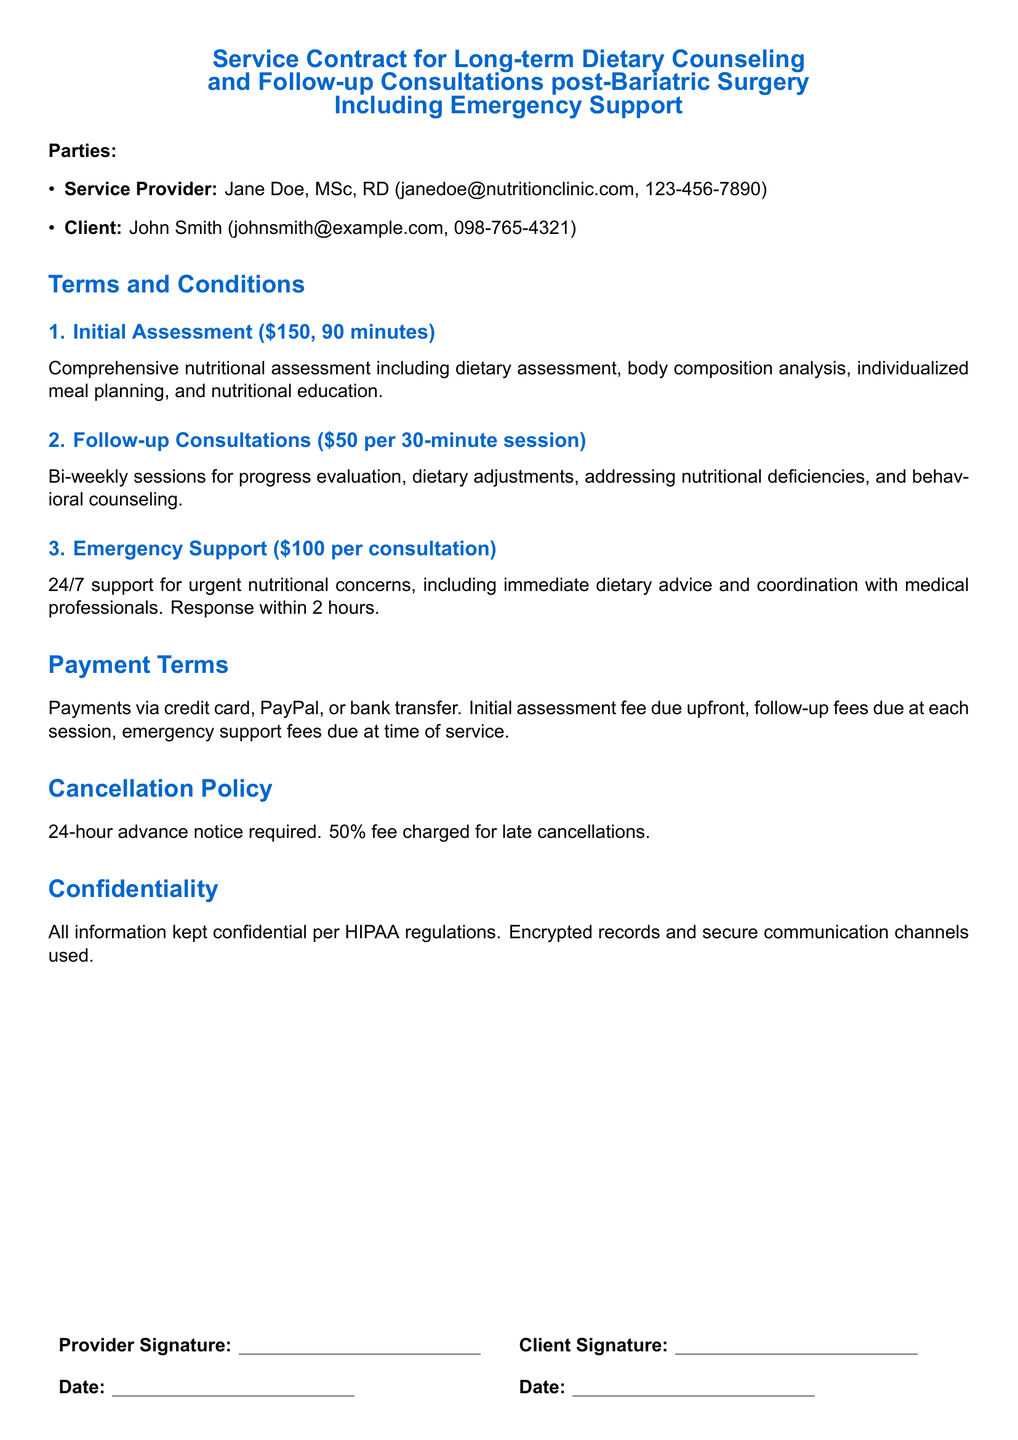What is the name of the service provider? The service provider is specifically named in the document, which is Jane Doe.
Answer: Jane Doe What is the fee for the initial assessment? The fee for the initial assessment is clearly stated in the document.
Answer: $150 How long is the initial assessment session? The duration of the initial assessment session is provided in the terms.
Answer: 90 minutes What is included in the follow-up consultations? The document lists the purposes of follow-up consultations, such as progress evaluation and dietary adjustments.
Answer: Progress evaluation, dietary adjustments What is the cancellation notice period required? The document specifies the advance notice required to cancel a session.
Answer: 24-hour How much is the fee for emergency support consultations? The fee for emergency support is explicitly mentioned in the document.
Answer: $100 How soon will the emergency support respond? The document states the response time for emergency support consultations.
Answer: Within 2 hours What is the confidentiality protection mentioned in the document? The document refers to specific regulations governing confidentiality.
Answer: HIPAA regulations What is the payment method for services? The document lists accepted methods of payment for services rendered.
Answer: Credit card, PayPal, or bank transfer 